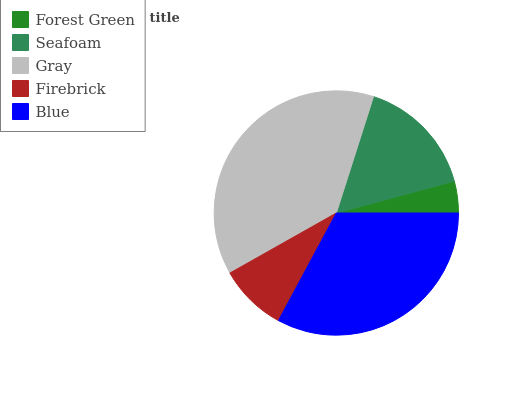Is Forest Green the minimum?
Answer yes or no. Yes. Is Gray the maximum?
Answer yes or no. Yes. Is Seafoam the minimum?
Answer yes or no. No. Is Seafoam the maximum?
Answer yes or no. No. Is Seafoam greater than Forest Green?
Answer yes or no. Yes. Is Forest Green less than Seafoam?
Answer yes or no. Yes. Is Forest Green greater than Seafoam?
Answer yes or no. No. Is Seafoam less than Forest Green?
Answer yes or no. No. Is Seafoam the high median?
Answer yes or no. Yes. Is Seafoam the low median?
Answer yes or no. Yes. Is Blue the high median?
Answer yes or no. No. Is Blue the low median?
Answer yes or no. No. 